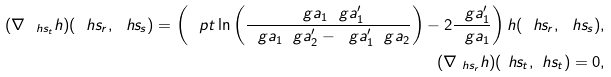<formula> <loc_0><loc_0><loc_500><loc_500>( \nabla _ { \ h s _ { t } } h ) ( \ h s _ { r } , \ h s _ { s } ) = \left ( \ p t \ln \left ( \frac { \ g a _ { 1 } \ g a _ { 1 } ^ { \prime } } { \ g a _ { 1 } \ g a _ { 2 } ^ { \prime } - \ g a _ { 1 } ^ { \prime } \ g a _ { 2 } } \right ) - 2 \frac { \ g a _ { 1 } ^ { \prime } } { \ g a _ { 1 } } \right ) h ( \ h s _ { r } , \ h s _ { s } ) , \\ ( \nabla _ { \ h s _ { r } } h ) ( \ h s _ { t } , \ h s _ { t } ) = 0 ,</formula> 